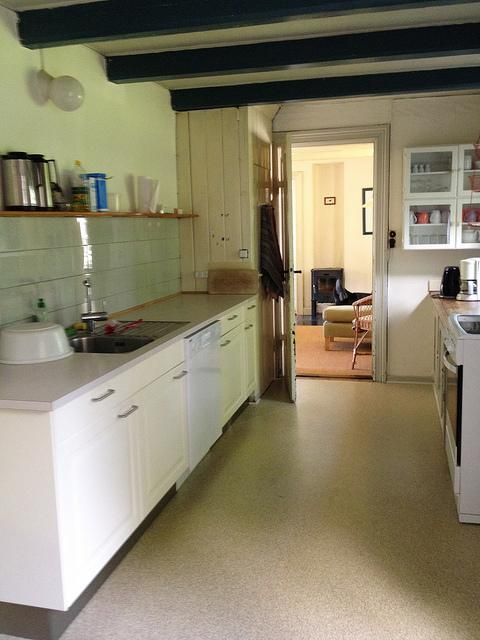What is the most likely activity the person on the yellow chair is doing? Please explain your reasoning. watching tv. The activity is watching tv. 